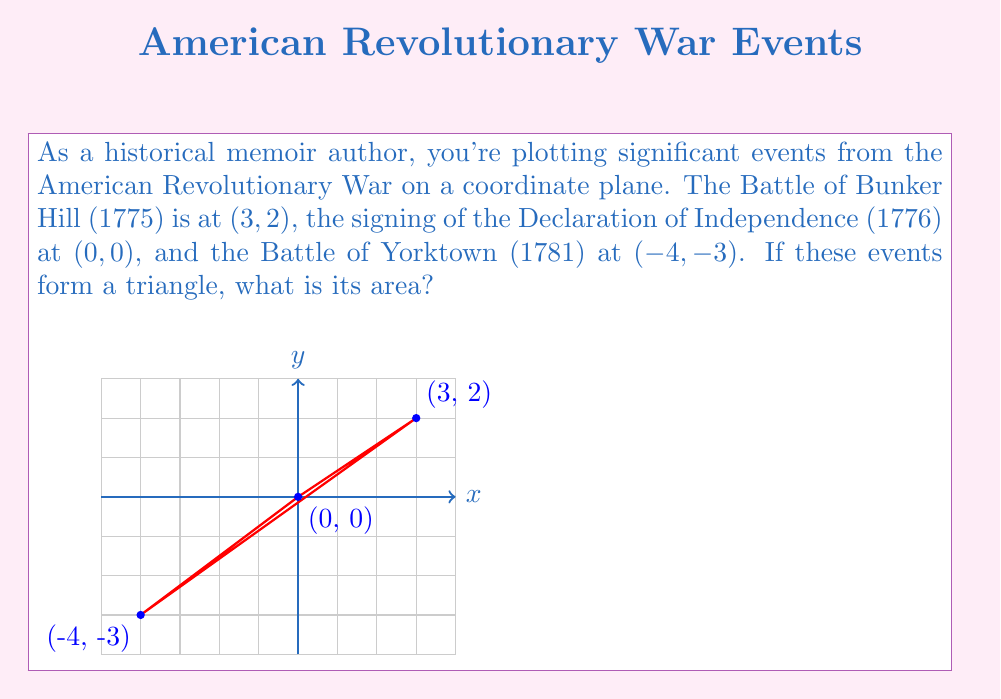Show me your answer to this math problem. To find the area of the triangle formed by these historical events, we can use the formula for the area of a triangle given the coordinates of its vertices:

$$A = \frac{1}{2}|x_1(y_2 - y_3) + x_2(y_3 - y_1) + x_3(y_1 - y_2)|$$

Where $(x_1, y_1)$, $(x_2, y_2)$, and $(x_3, y_3)$ are the coordinates of the three vertices.

Let's substitute our coordinates:
$(x_1, y_1) = (3, 2)$
$(x_2, y_2) = (0, 0)$
$(x_3, y_3) = (-4, -3)$

Now, let's calculate:

$$\begin{align}
A &= \frac{1}{2}|3(0 - (-3)) + 0((-3) - 2) + (-4)(2 - 0)| \\
&= \frac{1}{2}|3(3) + 0(-5) + (-4)(2)| \\
&= \frac{1}{2}|9 + 0 - 8| \\
&= \frac{1}{2}|1| \\
&= \frac{1}{2}
\end{align}$$

Therefore, the area of the triangle is $\frac{1}{2}$ square units.
Answer: $\frac{1}{2}$ square units 